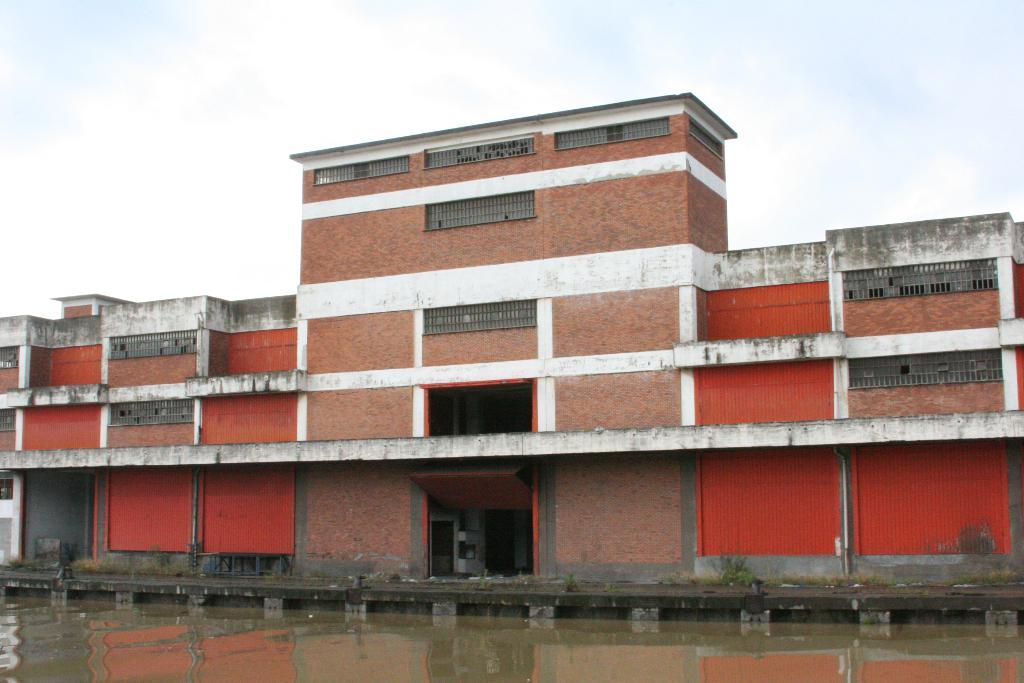What is the primary element visible in the image? There is water in the image. What can be seen besides the water? There is a path, plants, a building, and some objects in the image. Can you describe the setting of the image? The image features a natural setting with water, plants, and a path, as well as a man-made structure (the building). What is visible in the background of the image? The sky is visible in the background of the image. What type of sheet is being used to polish the teeth in the image? There is no sheet or teeth present in the image; it features water, a path, plants, a building, and some objects. 